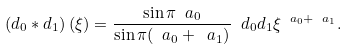<formula> <loc_0><loc_0><loc_500><loc_500>\left ( d _ { 0 } \ast d _ { 1 } \right ) ( \xi ) = \frac { \sin { \pi \ a _ { 0 } } } { \sin { \pi ( \ a _ { 0 } + \ a _ { 1 } ) } } \ d _ { 0 } d _ { 1 } \xi ^ { \ a _ { 0 } + \ a _ { 1 } } .</formula> 